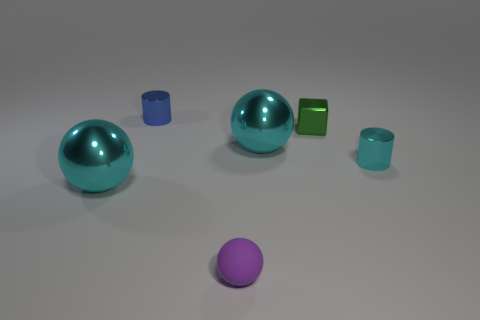There is a block that is the same material as the small cyan cylinder; what color is it?
Your answer should be compact. Green. What number of big cyan shiny objects are on the right side of the cyan metal thing that is on the left side of the metallic cylinder behind the tiny cyan thing?
Your answer should be very brief. 1. Is there any other thing that has the same shape as the green thing?
Make the answer very short. No. How many objects are tiny objects that are left of the cyan shiny cylinder or large cyan things?
Your response must be concise. 5. There is a ball to the right of the tiny purple rubber sphere; is its color the same as the rubber object?
Keep it short and to the point. No. There is a big shiny thing to the right of the cylinder that is behind the green cube; what is its shape?
Offer a very short reply. Sphere. Are there fewer cylinders that are in front of the tiny cyan cylinder than tiny blue metallic objects right of the tiny blue metallic object?
Your response must be concise. No. There is a cyan metallic thing that is the same shape as the blue object; what is its size?
Your answer should be compact. Small. Is there anything else that has the same size as the purple rubber thing?
Ensure brevity in your answer.  Yes. What number of things are either matte things in front of the small cyan shiny cylinder or spheres behind the purple matte sphere?
Provide a succinct answer. 3. 